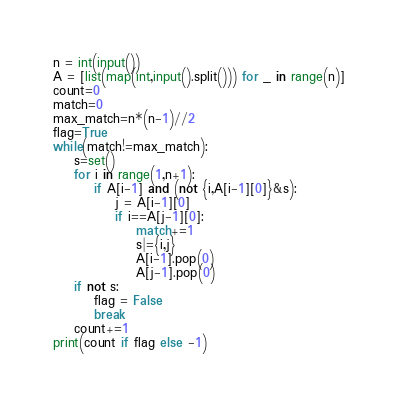<code> <loc_0><loc_0><loc_500><loc_500><_Python_>n = int(input())
A = [list(map(int,input().split())) for _ in range(n)]
count=0
match=0
max_match=n*(n-1)//2
flag=True
while(match!=max_match):
    s=set()
    for i in range(1,n+1):
        if A[i-1] and (not {i,A[i-1][0]}&s):
            j = A[i-1][0]
            if i==A[j-1][0]:
                match+=1
                s|={i,j}
                A[i-1].pop(0)
                A[j-1].pop(0)
    if not s:
        flag = False
        break
    count+=1
print(count if flag else -1)</code> 